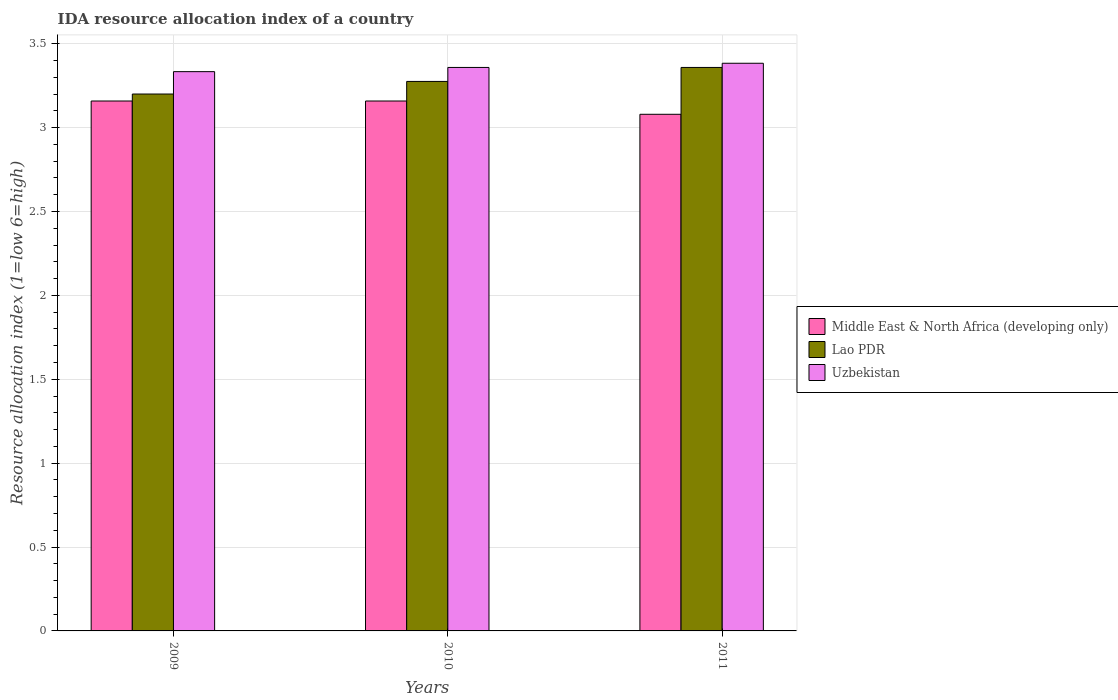Are the number of bars on each tick of the X-axis equal?
Offer a very short reply. Yes. In how many cases, is the number of bars for a given year not equal to the number of legend labels?
Make the answer very short. 0. What is the IDA resource allocation index in Lao PDR in 2011?
Give a very brief answer. 3.36. Across all years, what is the maximum IDA resource allocation index in Lao PDR?
Offer a terse response. 3.36. In which year was the IDA resource allocation index in Lao PDR minimum?
Offer a very short reply. 2009. What is the total IDA resource allocation index in Lao PDR in the graph?
Make the answer very short. 9.83. What is the difference between the IDA resource allocation index in Uzbekistan in 2009 and that in 2010?
Provide a short and direct response. -0.02. What is the difference between the IDA resource allocation index in Middle East & North Africa (developing only) in 2011 and the IDA resource allocation index in Uzbekistan in 2009?
Offer a very short reply. -0.25. What is the average IDA resource allocation index in Lao PDR per year?
Make the answer very short. 3.28. In the year 2009, what is the difference between the IDA resource allocation index in Middle East & North Africa (developing only) and IDA resource allocation index in Uzbekistan?
Provide a short and direct response. -0.17. What is the ratio of the IDA resource allocation index in Lao PDR in 2010 to that in 2011?
Your answer should be compact. 0.98. Is the IDA resource allocation index in Uzbekistan in 2009 less than that in 2010?
Ensure brevity in your answer.  Yes. What is the difference between the highest and the second highest IDA resource allocation index in Uzbekistan?
Make the answer very short. 0.03. What is the difference between the highest and the lowest IDA resource allocation index in Lao PDR?
Provide a succinct answer. 0.16. What does the 2nd bar from the left in 2009 represents?
Ensure brevity in your answer.  Lao PDR. What does the 3rd bar from the right in 2010 represents?
Offer a very short reply. Middle East & North Africa (developing only). What is the difference between two consecutive major ticks on the Y-axis?
Your answer should be compact. 0.5. Are the values on the major ticks of Y-axis written in scientific E-notation?
Ensure brevity in your answer.  No. Does the graph contain any zero values?
Provide a succinct answer. No. Does the graph contain grids?
Make the answer very short. Yes. How many legend labels are there?
Your response must be concise. 3. How are the legend labels stacked?
Ensure brevity in your answer.  Vertical. What is the title of the graph?
Provide a succinct answer. IDA resource allocation index of a country. What is the label or title of the Y-axis?
Your answer should be compact. Resource allocation index (1=low 6=high). What is the Resource allocation index (1=low 6=high) in Middle East & North Africa (developing only) in 2009?
Your answer should be very brief. 3.16. What is the Resource allocation index (1=low 6=high) in Uzbekistan in 2009?
Make the answer very short. 3.33. What is the Resource allocation index (1=low 6=high) in Middle East & North Africa (developing only) in 2010?
Your answer should be compact. 3.16. What is the Resource allocation index (1=low 6=high) in Lao PDR in 2010?
Your answer should be compact. 3.27. What is the Resource allocation index (1=low 6=high) of Uzbekistan in 2010?
Provide a succinct answer. 3.36. What is the Resource allocation index (1=low 6=high) in Middle East & North Africa (developing only) in 2011?
Offer a very short reply. 3.08. What is the Resource allocation index (1=low 6=high) in Lao PDR in 2011?
Offer a terse response. 3.36. What is the Resource allocation index (1=low 6=high) of Uzbekistan in 2011?
Make the answer very short. 3.38. Across all years, what is the maximum Resource allocation index (1=low 6=high) in Middle East & North Africa (developing only)?
Your response must be concise. 3.16. Across all years, what is the maximum Resource allocation index (1=low 6=high) in Lao PDR?
Keep it short and to the point. 3.36. Across all years, what is the maximum Resource allocation index (1=low 6=high) in Uzbekistan?
Offer a very short reply. 3.38. Across all years, what is the minimum Resource allocation index (1=low 6=high) in Middle East & North Africa (developing only)?
Provide a short and direct response. 3.08. Across all years, what is the minimum Resource allocation index (1=low 6=high) of Uzbekistan?
Your response must be concise. 3.33. What is the total Resource allocation index (1=low 6=high) of Middle East & North Africa (developing only) in the graph?
Provide a short and direct response. 9.4. What is the total Resource allocation index (1=low 6=high) of Lao PDR in the graph?
Make the answer very short. 9.83. What is the total Resource allocation index (1=low 6=high) of Uzbekistan in the graph?
Offer a very short reply. 10.07. What is the difference between the Resource allocation index (1=low 6=high) of Lao PDR in 2009 and that in 2010?
Provide a succinct answer. -0.07. What is the difference between the Resource allocation index (1=low 6=high) of Uzbekistan in 2009 and that in 2010?
Give a very brief answer. -0.03. What is the difference between the Resource allocation index (1=low 6=high) in Middle East & North Africa (developing only) in 2009 and that in 2011?
Ensure brevity in your answer.  0.08. What is the difference between the Resource allocation index (1=low 6=high) in Lao PDR in 2009 and that in 2011?
Offer a very short reply. -0.16. What is the difference between the Resource allocation index (1=low 6=high) of Uzbekistan in 2009 and that in 2011?
Give a very brief answer. -0.05. What is the difference between the Resource allocation index (1=low 6=high) in Middle East & North Africa (developing only) in 2010 and that in 2011?
Your answer should be very brief. 0.08. What is the difference between the Resource allocation index (1=low 6=high) in Lao PDR in 2010 and that in 2011?
Provide a short and direct response. -0.08. What is the difference between the Resource allocation index (1=low 6=high) of Uzbekistan in 2010 and that in 2011?
Give a very brief answer. -0.03. What is the difference between the Resource allocation index (1=low 6=high) in Middle East & North Africa (developing only) in 2009 and the Resource allocation index (1=low 6=high) in Lao PDR in 2010?
Your answer should be compact. -0.12. What is the difference between the Resource allocation index (1=low 6=high) in Lao PDR in 2009 and the Resource allocation index (1=low 6=high) in Uzbekistan in 2010?
Offer a very short reply. -0.16. What is the difference between the Resource allocation index (1=low 6=high) of Middle East & North Africa (developing only) in 2009 and the Resource allocation index (1=low 6=high) of Lao PDR in 2011?
Make the answer very short. -0.2. What is the difference between the Resource allocation index (1=low 6=high) in Middle East & North Africa (developing only) in 2009 and the Resource allocation index (1=low 6=high) in Uzbekistan in 2011?
Keep it short and to the point. -0.23. What is the difference between the Resource allocation index (1=low 6=high) of Lao PDR in 2009 and the Resource allocation index (1=low 6=high) of Uzbekistan in 2011?
Your response must be concise. -0.18. What is the difference between the Resource allocation index (1=low 6=high) in Middle East & North Africa (developing only) in 2010 and the Resource allocation index (1=low 6=high) in Uzbekistan in 2011?
Provide a short and direct response. -0.23. What is the difference between the Resource allocation index (1=low 6=high) in Lao PDR in 2010 and the Resource allocation index (1=low 6=high) in Uzbekistan in 2011?
Keep it short and to the point. -0.11. What is the average Resource allocation index (1=low 6=high) in Middle East & North Africa (developing only) per year?
Your answer should be very brief. 3.13. What is the average Resource allocation index (1=low 6=high) of Lao PDR per year?
Your answer should be compact. 3.28. What is the average Resource allocation index (1=low 6=high) in Uzbekistan per year?
Your answer should be compact. 3.36. In the year 2009, what is the difference between the Resource allocation index (1=low 6=high) of Middle East & North Africa (developing only) and Resource allocation index (1=low 6=high) of Lao PDR?
Provide a short and direct response. -0.04. In the year 2009, what is the difference between the Resource allocation index (1=low 6=high) in Middle East & North Africa (developing only) and Resource allocation index (1=low 6=high) in Uzbekistan?
Your answer should be very brief. -0.17. In the year 2009, what is the difference between the Resource allocation index (1=low 6=high) in Lao PDR and Resource allocation index (1=low 6=high) in Uzbekistan?
Provide a short and direct response. -0.13. In the year 2010, what is the difference between the Resource allocation index (1=low 6=high) in Middle East & North Africa (developing only) and Resource allocation index (1=low 6=high) in Lao PDR?
Offer a terse response. -0.12. In the year 2010, what is the difference between the Resource allocation index (1=low 6=high) of Middle East & North Africa (developing only) and Resource allocation index (1=low 6=high) of Uzbekistan?
Offer a very short reply. -0.2. In the year 2010, what is the difference between the Resource allocation index (1=low 6=high) of Lao PDR and Resource allocation index (1=low 6=high) of Uzbekistan?
Ensure brevity in your answer.  -0.08. In the year 2011, what is the difference between the Resource allocation index (1=low 6=high) of Middle East & North Africa (developing only) and Resource allocation index (1=low 6=high) of Lao PDR?
Offer a terse response. -0.28. In the year 2011, what is the difference between the Resource allocation index (1=low 6=high) of Middle East & North Africa (developing only) and Resource allocation index (1=low 6=high) of Uzbekistan?
Provide a short and direct response. -0.3. In the year 2011, what is the difference between the Resource allocation index (1=low 6=high) in Lao PDR and Resource allocation index (1=low 6=high) in Uzbekistan?
Your answer should be compact. -0.03. What is the ratio of the Resource allocation index (1=low 6=high) of Middle East & North Africa (developing only) in 2009 to that in 2010?
Your response must be concise. 1. What is the ratio of the Resource allocation index (1=low 6=high) of Lao PDR in 2009 to that in 2010?
Offer a very short reply. 0.98. What is the ratio of the Resource allocation index (1=low 6=high) of Uzbekistan in 2009 to that in 2010?
Make the answer very short. 0.99. What is the ratio of the Resource allocation index (1=low 6=high) in Middle East & North Africa (developing only) in 2009 to that in 2011?
Your response must be concise. 1.03. What is the ratio of the Resource allocation index (1=low 6=high) in Lao PDR in 2009 to that in 2011?
Offer a terse response. 0.95. What is the ratio of the Resource allocation index (1=low 6=high) of Uzbekistan in 2009 to that in 2011?
Your response must be concise. 0.99. What is the ratio of the Resource allocation index (1=low 6=high) of Middle East & North Africa (developing only) in 2010 to that in 2011?
Provide a short and direct response. 1.03. What is the ratio of the Resource allocation index (1=low 6=high) of Lao PDR in 2010 to that in 2011?
Give a very brief answer. 0.98. What is the difference between the highest and the second highest Resource allocation index (1=low 6=high) of Lao PDR?
Ensure brevity in your answer.  0.08. What is the difference between the highest and the second highest Resource allocation index (1=low 6=high) of Uzbekistan?
Make the answer very short. 0.03. What is the difference between the highest and the lowest Resource allocation index (1=low 6=high) of Middle East & North Africa (developing only)?
Ensure brevity in your answer.  0.08. What is the difference between the highest and the lowest Resource allocation index (1=low 6=high) in Lao PDR?
Ensure brevity in your answer.  0.16. What is the difference between the highest and the lowest Resource allocation index (1=low 6=high) of Uzbekistan?
Offer a terse response. 0.05. 